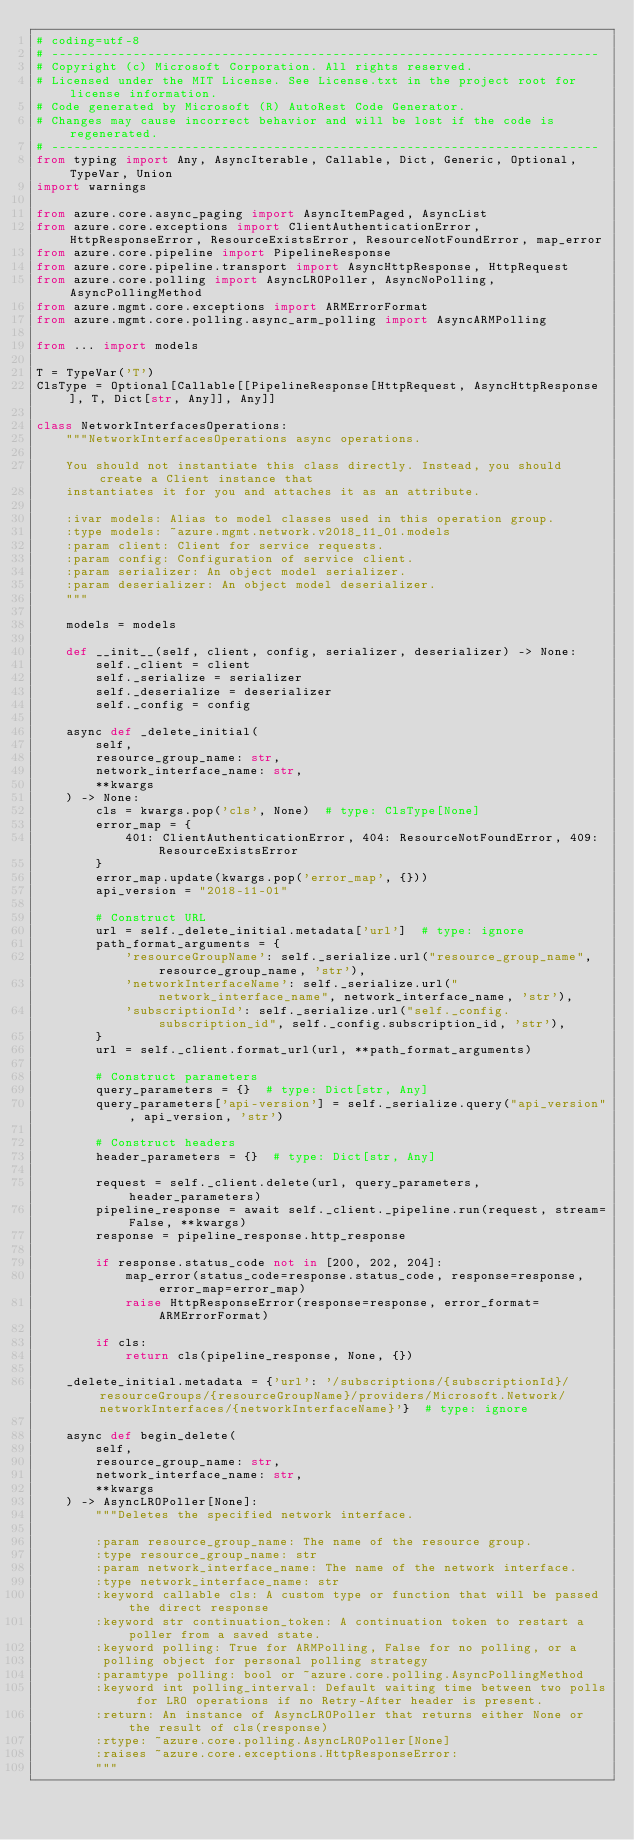Convert code to text. <code><loc_0><loc_0><loc_500><loc_500><_Python_># coding=utf-8
# --------------------------------------------------------------------------
# Copyright (c) Microsoft Corporation. All rights reserved.
# Licensed under the MIT License. See License.txt in the project root for license information.
# Code generated by Microsoft (R) AutoRest Code Generator.
# Changes may cause incorrect behavior and will be lost if the code is regenerated.
# --------------------------------------------------------------------------
from typing import Any, AsyncIterable, Callable, Dict, Generic, Optional, TypeVar, Union
import warnings

from azure.core.async_paging import AsyncItemPaged, AsyncList
from azure.core.exceptions import ClientAuthenticationError, HttpResponseError, ResourceExistsError, ResourceNotFoundError, map_error
from azure.core.pipeline import PipelineResponse
from azure.core.pipeline.transport import AsyncHttpResponse, HttpRequest
from azure.core.polling import AsyncLROPoller, AsyncNoPolling, AsyncPollingMethod
from azure.mgmt.core.exceptions import ARMErrorFormat
from azure.mgmt.core.polling.async_arm_polling import AsyncARMPolling

from ... import models

T = TypeVar('T')
ClsType = Optional[Callable[[PipelineResponse[HttpRequest, AsyncHttpResponse], T, Dict[str, Any]], Any]]

class NetworkInterfacesOperations:
    """NetworkInterfacesOperations async operations.

    You should not instantiate this class directly. Instead, you should create a Client instance that
    instantiates it for you and attaches it as an attribute.

    :ivar models: Alias to model classes used in this operation group.
    :type models: ~azure.mgmt.network.v2018_11_01.models
    :param client: Client for service requests.
    :param config: Configuration of service client.
    :param serializer: An object model serializer.
    :param deserializer: An object model deserializer.
    """

    models = models

    def __init__(self, client, config, serializer, deserializer) -> None:
        self._client = client
        self._serialize = serializer
        self._deserialize = deserializer
        self._config = config

    async def _delete_initial(
        self,
        resource_group_name: str,
        network_interface_name: str,
        **kwargs
    ) -> None:
        cls = kwargs.pop('cls', None)  # type: ClsType[None]
        error_map = {
            401: ClientAuthenticationError, 404: ResourceNotFoundError, 409: ResourceExistsError
        }
        error_map.update(kwargs.pop('error_map', {}))
        api_version = "2018-11-01"

        # Construct URL
        url = self._delete_initial.metadata['url']  # type: ignore
        path_format_arguments = {
            'resourceGroupName': self._serialize.url("resource_group_name", resource_group_name, 'str'),
            'networkInterfaceName': self._serialize.url("network_interface_name", network_interface_name, 'str'),
            'subscriptionId': self._serialize.url("self._config.subscription_id", self._config.subscription_id, 'str'),
        }
        url = self._client.format_url(url, **path_format_arguments)

        # Construct parameters
        query_parameters = {}  # type: Dict[str, Any]
        query_parameters['api-version'] = self._serialize.query("api_version", api_version, 'str')

        # Construct headers
        header_parameters = {}  # type: Dict[str, Any]

        request = self._client.delete(url, query_parameters, header_parameters)
        pipeline_response = await self._client._pipeline.run(request, stream=False, **kwargs)
        response = pipeline_response.http_response

        if response.status_code not in [200, 202, 204]:
            map_error(status_code=response.status_code, response=response, error_map=error_map)
            raise HttpResponseError(response=response, error_format=ARMErrorFormat)

        if cls:
            return cls(pipeline_response, None, {})

    _delete_initial.metadata = {'url': '/subscriptions/{subscriptionId}/resourceGroups/{resourceGroupName}/providers/Microsoft.Network/networkInterfaces/{networkInterfaceName}'}  # type: ignore

    async def begin_delete(
        self,
        resource_group_name: str,
        network_interface_name: str,
        **kwargs
    ) -> AsyncLROPoller[None]:
        """Deletes the specified network interface.

        :param resource_group_name: The name of the resource group.
        :type resource_group_name: str
        :param network_interface_name: The name of the network interface.
        :type network_interface_name: str
        :keyword callable cls: A custom type or function that will be passed the direct response
        :keyword str continuation_token: A continuation token to restart a poller from a saved state.
        :keyword polling: True for ARMPolling, False for no polling, or a
         polling object for personal polling strategy
        :paramtype polling: bool or ~azure.core.polling.AsyncPollingMethod
        :keyword int polling_interval: Default waiting time between two polls for LRO operations if no Retry-After header is present.
        :return: An instance of AsyncLROPoller that returns either None or the result of cls(response)
        :rtype: ~azure.core.polling.AsyncLROPoller[None]
        :raises ~azure.core.exceptions.HttpResponseError:
        """</code> 